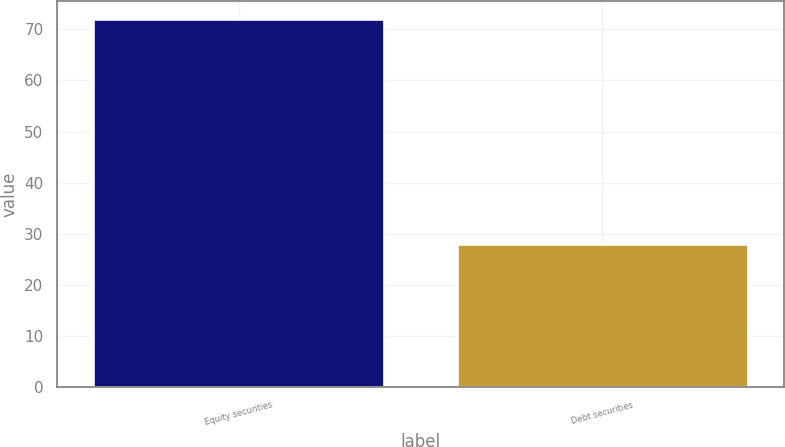Convert chart. <chart><loc_0><loc_0><loc_500><loc_500><bar_chart><fcel>Equity securities<fcel>Debt securities<nl><fcel>72<fcel>28<nl></chart> 